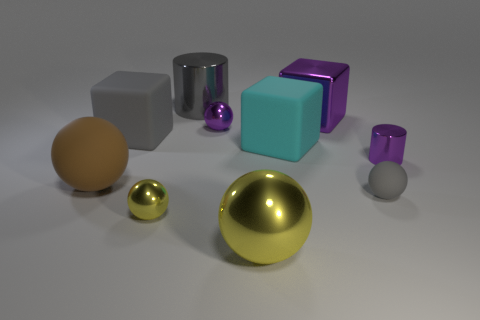There is a large block that is the same color as the large cylinder; what is it made of?
Provide a succinct answer. Rubber. Does the small sphere left of the large cylinder have the same material as the cyan object?
Ensure brevity in your answer.  No. Is the number of cylinders in front of the small purple shiny sphere the same as the number of small metal cylinders in front of the large brown rubber sphere?
Provide a succinct answer. No. Is there any other thing that is the same size as the purple metallic ball?
Your response must be concise. Yes. What material is the big yellow thing that is the same shape as the large brown object?
Offer a very short reply. Metal. Are there any small purple objects behind the matte cube that is on the right side of the metallic cylinder on the left side of the small purple cylinder?
Provide a short and direct response. Yes. There is a yellow metal object to the right of the big cylinder; is its shape the same as the large rubber object that is to the right of the big gray shiny thing?
Offer a very short reply. No. Is the number of large cyan blocks behind the big purple thing greater than the number of green spheres?
Offer a terse response. No. How many objects are tiny yellow shiny things or cyan blocks?
Your answer should be compact. 2. The tiny cylinder has what color?
Offer a very short reply. Purple. 